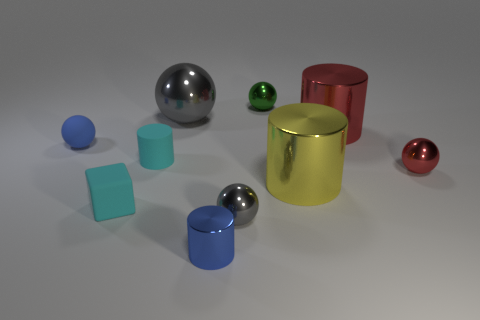Is the tiny cyan cylinder made of the same material as the blue ball?
Provide a short and direct response. Yes. There is a tiny cylinder that is behind the tiny matte block; how many large cylinders are in front of it?
Provide a short and direct response. 1. There is a small rubber object behind the cyan rubber cylinder; does it have the same color as the tiny shiny cylinder?
Your answer should be compact. Yes. What number of things are cyan matte objects or tiny metallic things to the left of the yellow shiny thing?
Your answer should be very brief. 5. There is a gray metal thing that is in front of the big sphere; is its shape the same as the blue thing behind the small cyan cube?
Offer a terse response. Yes. What is the shape of the tiny gray thing that is the same material as the green ball?
Ensure brevity in your answer.  Sphere. What is the material of the cylinder that is on the left side of the yellow metal object and on the right side of the big gray metal sphere?
Provide a short and direct response. Metal. Is the color of the matte sphere the same as the small metal cylinder?
Your answer should be very brief. Yes. There is a thing that is the same color as the small rubber sphere; what is its shape?
Provide a succinct answer. Cylinder. What number of other rubber things are the same shape as the tiny green thing?
Give a very brief answer. 1. 